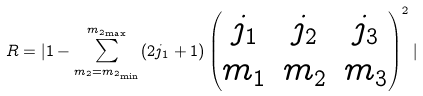<formula> <loc_0><loc_0><loc_500><loc_500>R = | 1 - \sum _ { m _ { 2 } = m _ { 2 _ { \min } } } ^ { m _ { 2 _ { \max } } } ( 2 j _ { 1 } + 1 ) \begin{pmatrix} j _ { 1 } & j _ { 2 } & j _ { 3 } \\ m _ { 1 } & m _ { 2 } & m _ { 3 } \end{pmatrix} ^ { 2 } |</formula> 